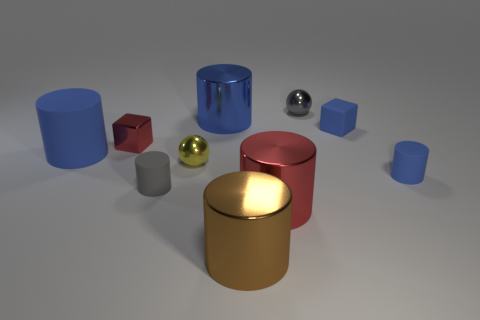Subtract all purple blocks. How many blue cylinders are left? 3 Subtract all big rubber cylinders. How many cylinders are left? 5 Subtract all gray cylinders. How many cylinders are left? 5 Subtract 3 cylinders. How many cylinders are left? 3 Subtract all purple cylinders. Subtract all gray balls. How many cylinders are left? 6 Subtract all blocks. How many objects are left? 8 Subtract all large yellow metal blocks. Subtract all small gray spheres. How many objects are left? 9 Add 5 red metallic cylinders. How many red metallic cylinders are left? 6 Add 9 tiny red metallic cylinders. How many tiny red metallic cylinders exist? 9 Subtract 1 gray cylinders. How many objects are left? 9 